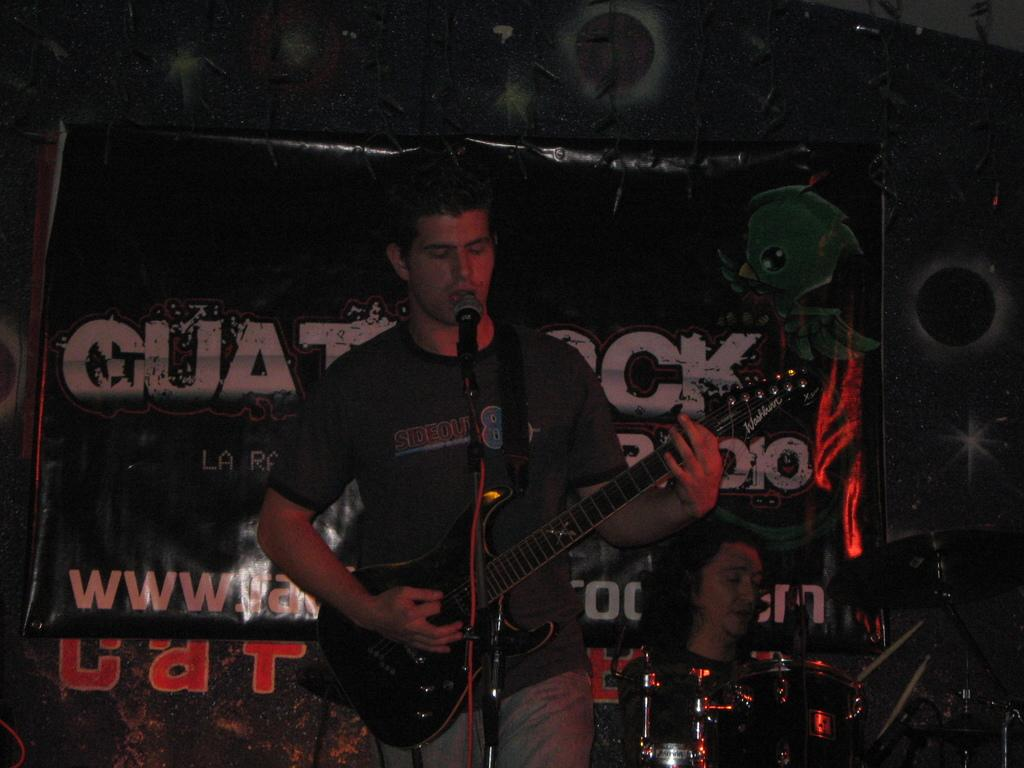Who is present in the image? There is a man in the image. What is the man doing in the image? The man is standing in the image. What object is the man holding in the image? The man is holding a guitar in the image. What object is in front of the man in the image? There is a microphone in front of the man in the image. What type of feast is being prepared on the guitar in the image? There is no feast or any indication of food preparation in the image; the man is simply holding a guitar. 